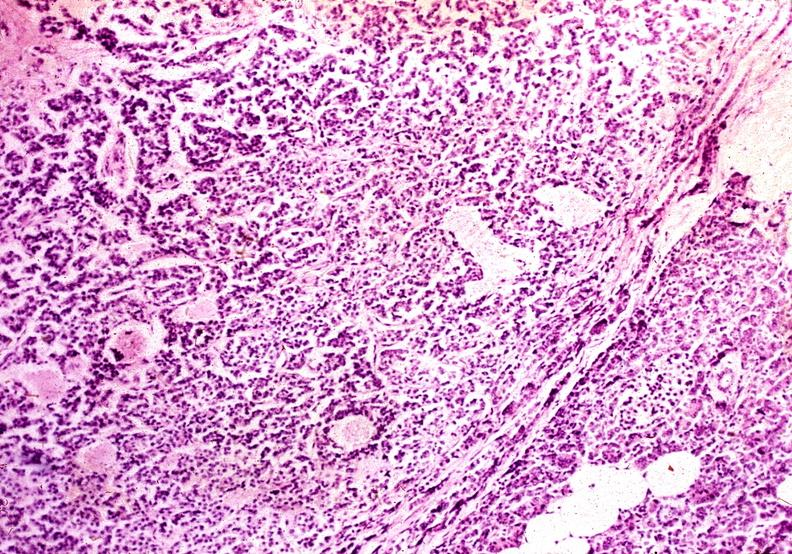where is this?
Answer the question using a single word or phrase. Pancreas 